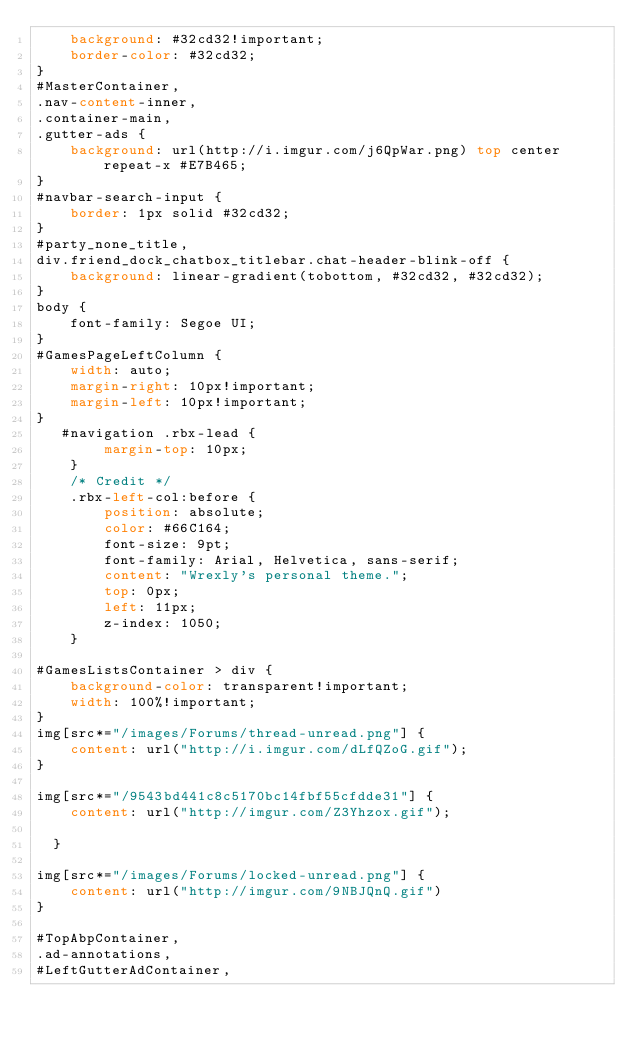Convert code to text. <code><loc_0><loc_0><loc_500><loc_500><_CSS_>    background: #32cd32!important;
    border-color: #32cd32;
}
#MasterContainer,
.nav-content-inner,
.container-main,
.gutter-ads {
    background: url(http://i.imgur.com/j6QpWar.png) top center repeat-x #E7B465;
}
#navbar-search-input {
    border: 1px solid #32cd32;
}
#party_none_title,
div.friend_dock_chatbox_titlebar.chat-header-blink-off {
    background: linear-gradient(tobottom, #32cd32, #32cd32);
}
body {
    font-family: Segoe UI;
}
#GamesPageLeftColumn {
    width: auto;
    margin-right: 10px!important;
    margin-left: 10px!important;
}
   #navigation .rbx-lead {
        margin-top: 10px;
    }
    /* Credit */
    .rbx-left-col:before {
        position: absolute;
        color: #66C164;
    	font-size: 9pt;
    	font-family: Arial, Helvetica, sans-serif;
    	content: "Wrexly's personal theme.";
    	top: 0px;
        left: 11px;
        z-index: 1050;
    }

#GamesListsContainer > div {
    background-color: transparent!important;
    width: 100%!important;
}
img[src*="/images/Forums/thread-unread.png"] {
    content: url("http://i.imgur.com/dLfQZoG.gif");
}
  
img[src*="/9543bd441c8c5170bc14fbf55cfdde31"] {
    content: url("http://imgur.com/Z3Yhzox.gif");
  
  }
 
img[src*="/images/Forums/locked-unread.png"] {
    content: url("http://imgur.com/9NBJQnQ.gif")
}

#TopAbpContainer,
.ad-annotations,
#LeftGutterAdContainer,</code> 